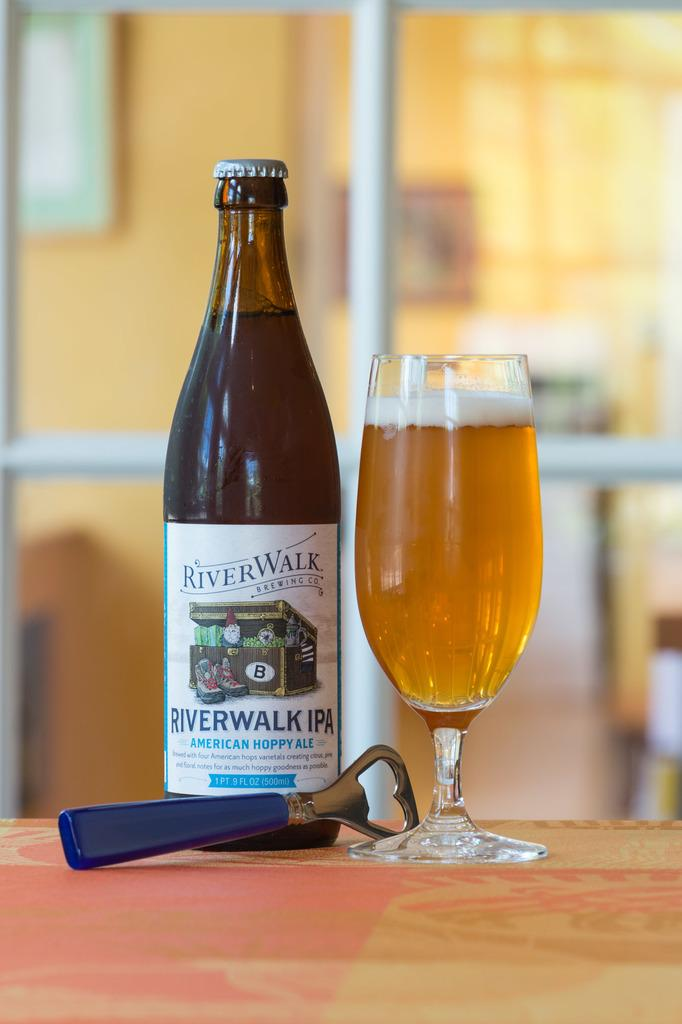<image>
Describe the image concisely. A bottle of Riverwalk beer is pictured with a bottle opener and a glass of beer. 